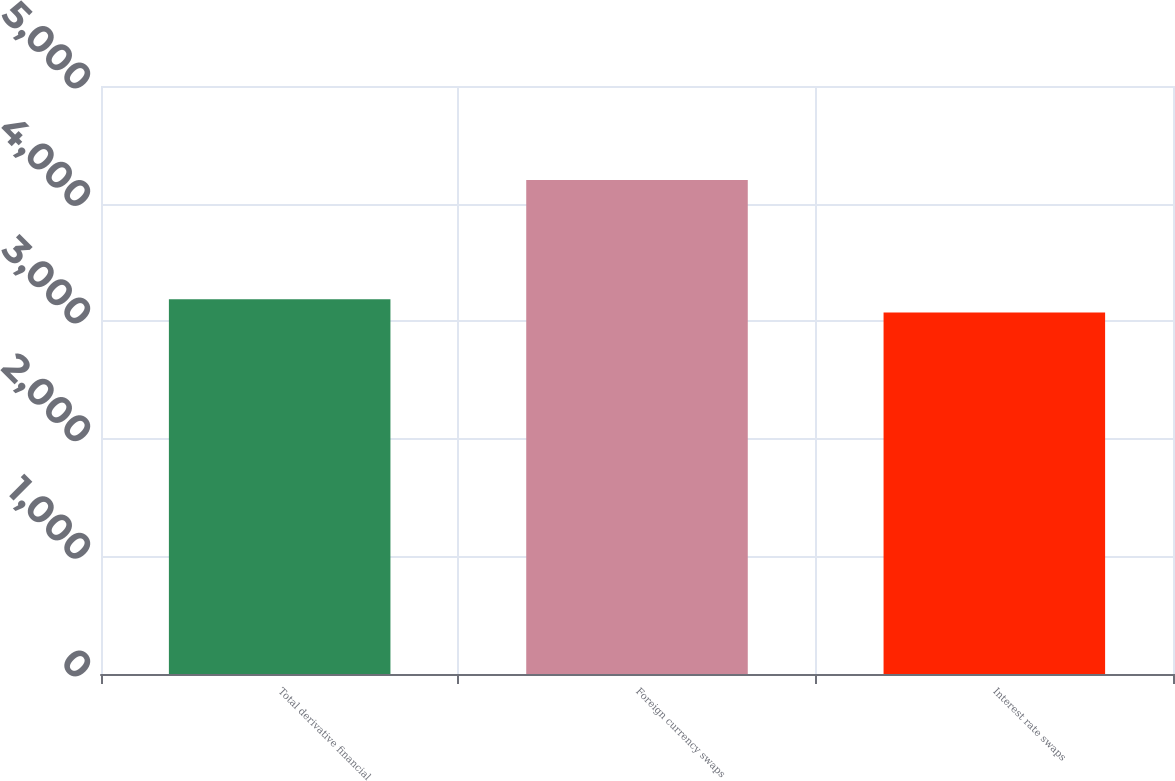Convert chart to OTSL. <chart><loc_0><loc_0><loc_500><loc_500><bar_chart><fcel>Total derivative financial<fcel>Foreign currency swaps<fcel>Interest rate swaps<nl><fcel>3186.7<fcel>4201<fcel>3074<nl></chart> 